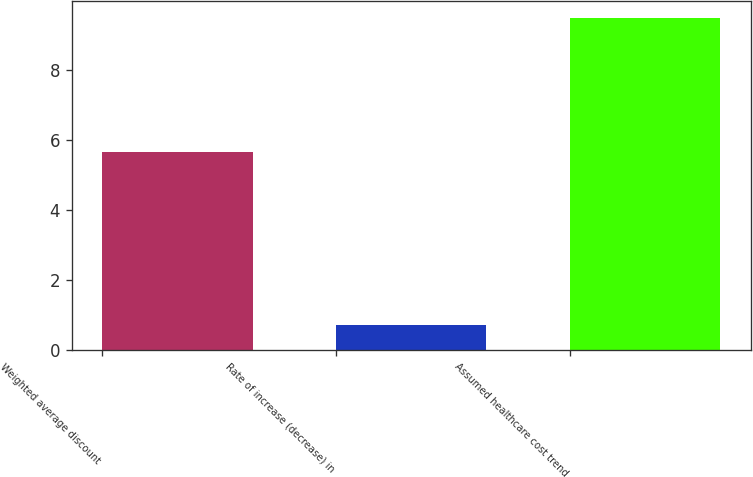<chart> <loc_0><loc_0><loc_500><loc_500><bar_chart><fcel>Weighted average discount<fcel>Rate of increase (decrease) in<fcel>Assumed healthcare cost trend<nl><fcel>5.65<fcel>0.72<fcel>9.5<nl></chart> 